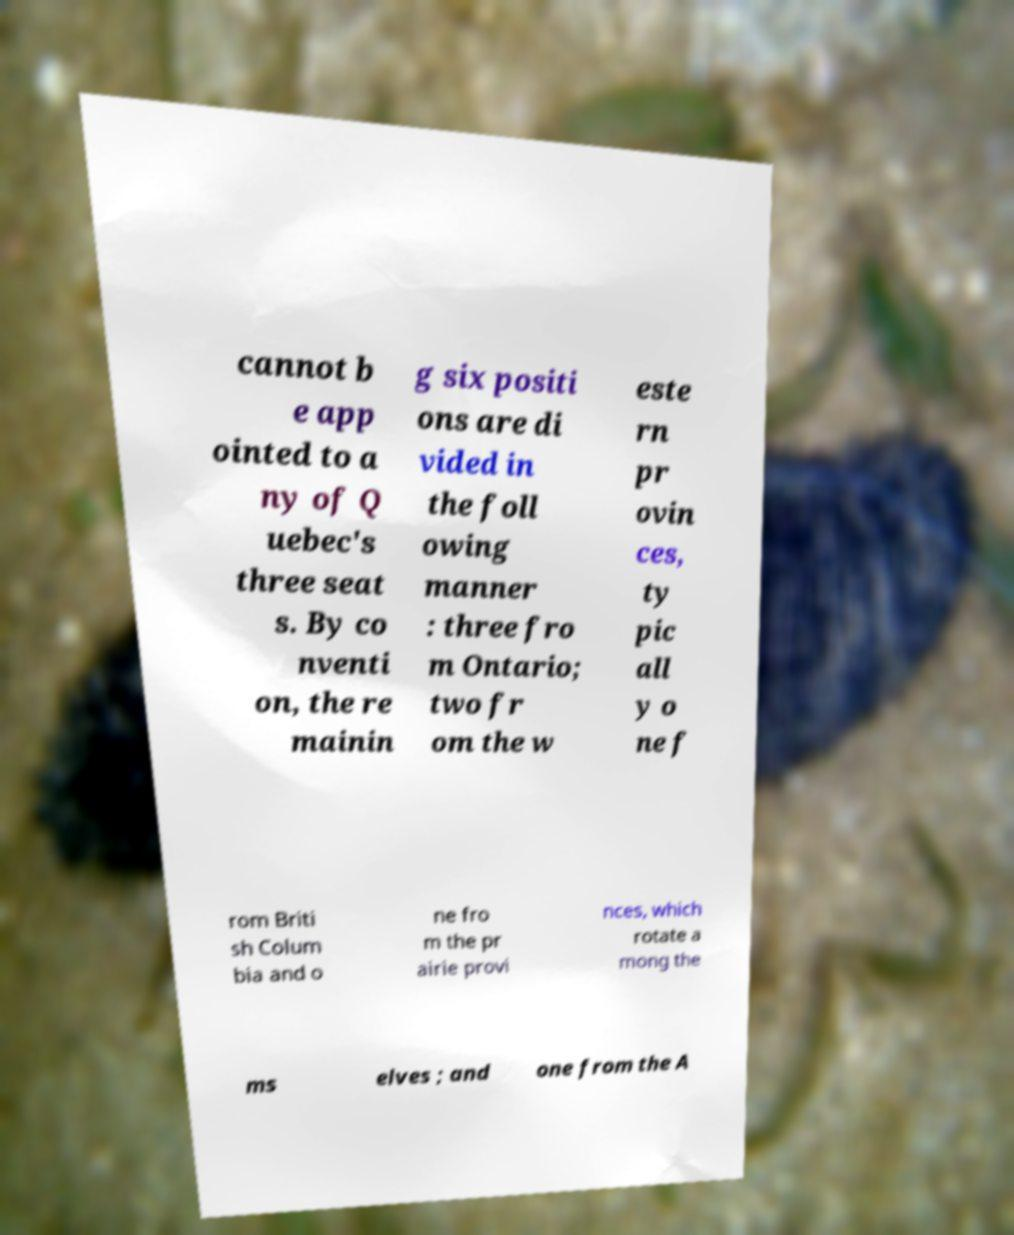Can you accurately transcribe the text from the provided image for me? cannot b e app ointed to a ny of Q uebec's three seat s. By co nventi on, the re mainin g six positi ons are di vided in the foll owing manner : three fro m Ontario; two fr om the w este rn pr ovin ces, ty pic all y o ne f rom Briti sh Colum bia and o ne fro m the pr airie provi nces, which rotate a mong the ms elves ; and one from the A 